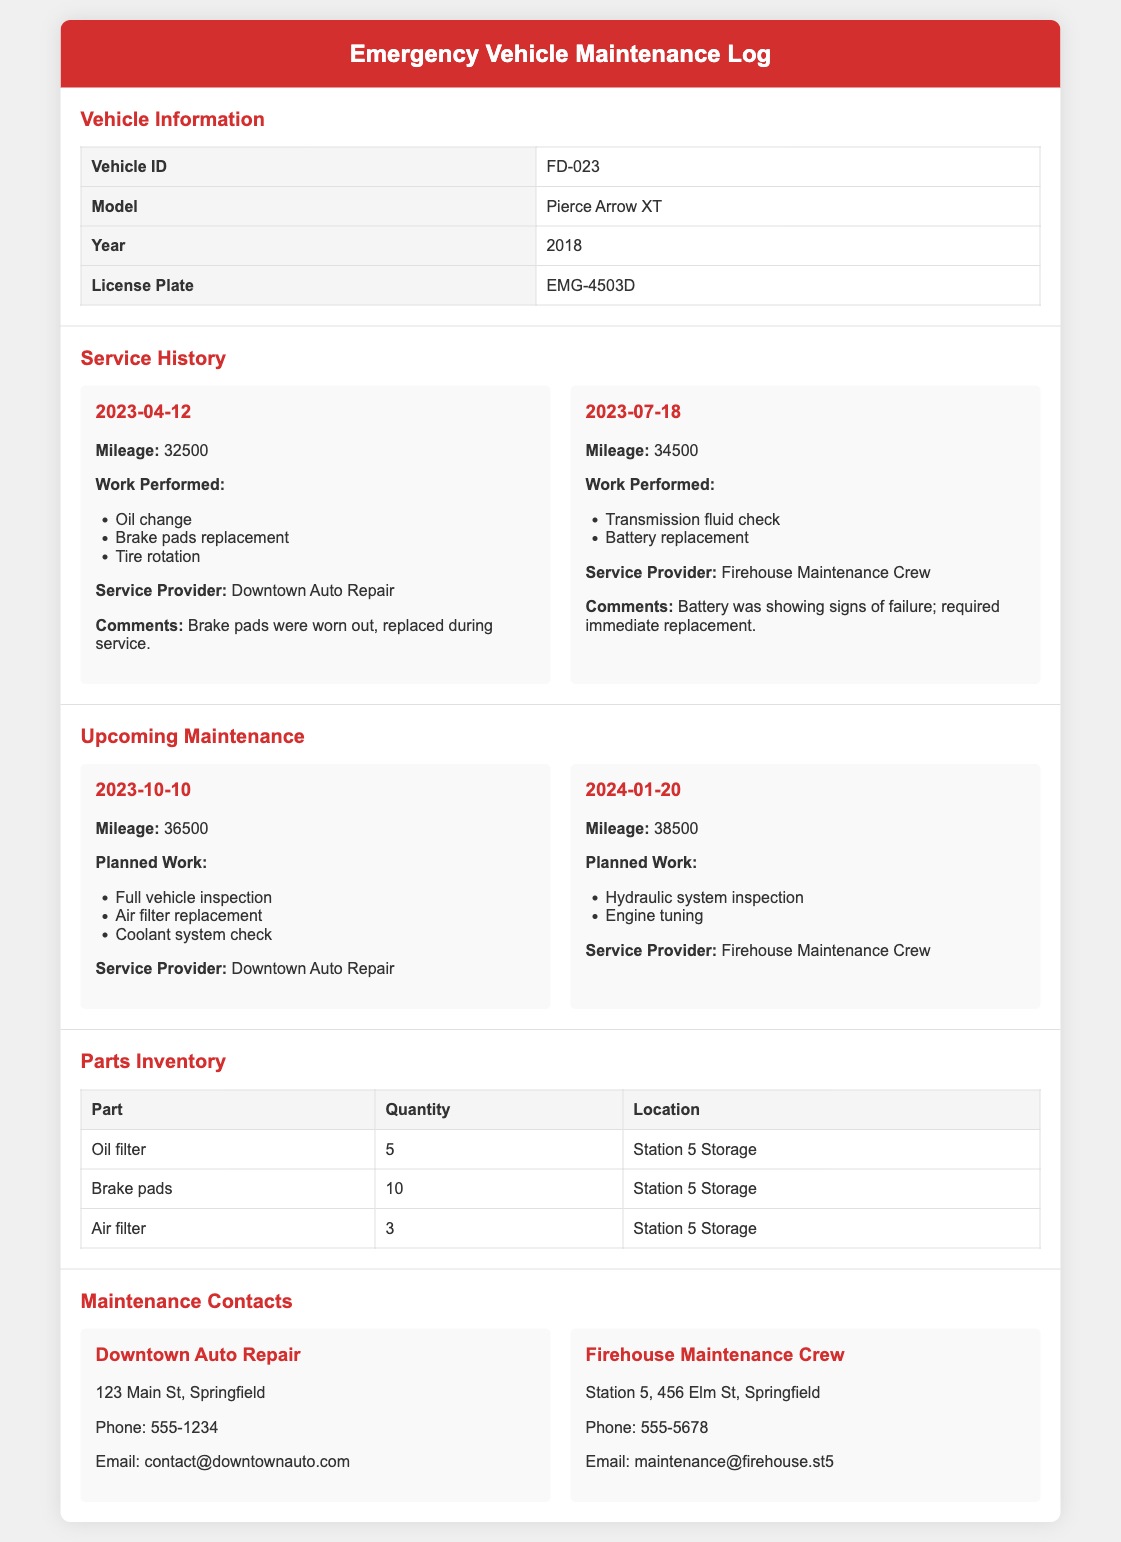What is the Vehicle ID? The Vehicle ID is explicitly mentioned in the vehicle information section of the document.
Answer: FD-023 What model is the vehicle? The model of the vehicle is specified in the table under Vehicle Information.
Answer: Pierce Arrow XT When was the last service performed? The last service date is listed under the Service History section, specifically for the most recent entry.
Answer: 2023-07-18 What work was performed during the last service? The work performed can be found in the details for the most recent service record.
Answer: Transmission fluid check, Battery replacement When is the next scheduled maintenance? The next scheduled maintenance date is given in the Upcoming Maintenance section and is clearly stated.
Answer: 2023-10-10 How many brake pads are available in inventory? The quantity of brake pads is listed in the Parts Inventory table.
Answer: 10 What will be checked during the upcoming maintenance on 2023-10-10? The planned work for the upcoming maintenance includes specific tasks listed under the relevant date.
Answer: Full vehicle inspection, Air filter replacement, Coolant system check What is the contact number for Downtown Auto Repair? The contact number can be found in the Maintenance Contacts section, specifically for Downtown Auto Repair.
Answer: 555-1234 Which maintenance crew provides service for hydraulic system inspections? The service provider for hydraulic system inspections is outlined in the upcoming maintenance section.
Answer: Firehouse Maintenance Crew 